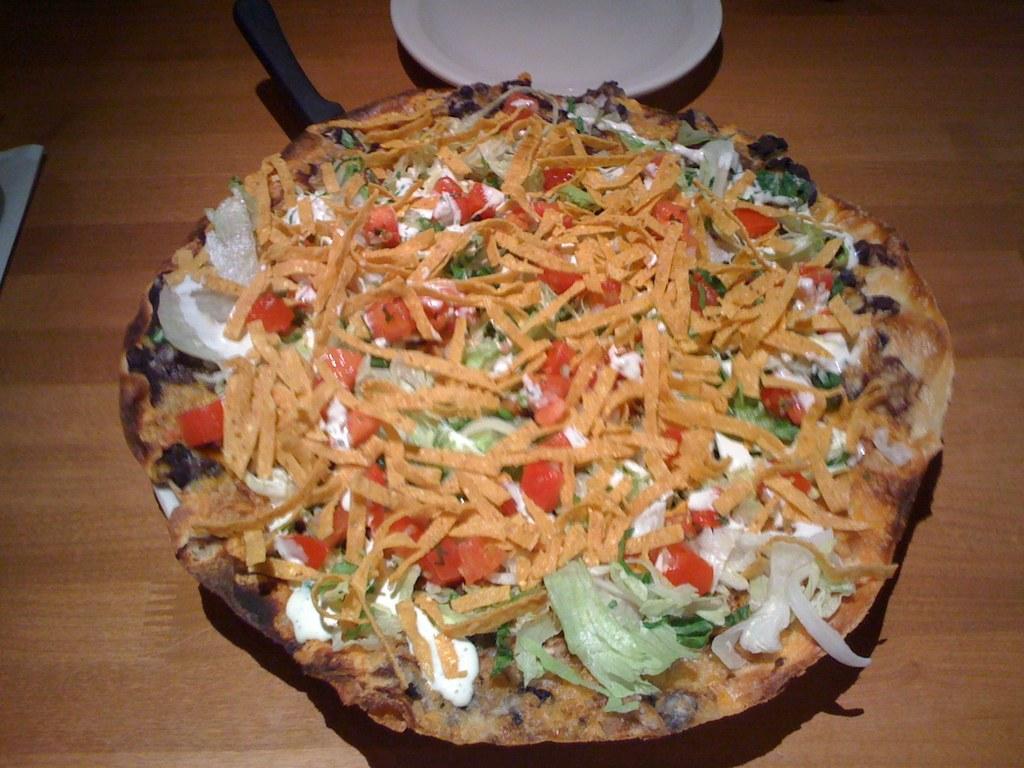Please provide a concise description of this image. In this picture we can see a plate here, there is some food here, at the bottom there is a wooden surface. 